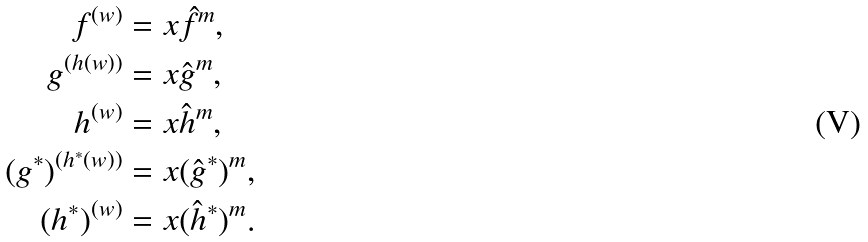Convert formula to latex. <formula><loc_0><loc_0><loc_500><loc_500>f ^ { ( w ) } & = x \hat { f } ^ { m } , \\ g ^ { ( h ( w ) ) } & = x \hat { g } ^ { m } , \\ h ^ { ( w ) } & = x \hat { h } ^ { m } , \\ ( g ^ { * } ) ^ { ( h ^ { * } ( w ) ) } & = x ( \hat { g } ^ { * } ) ^ { m } , \\ ( h ^ { * } ) ^ { ( w ) } & = x ( \hat { h } ^ { * } ) ^ { m } .</formula> 